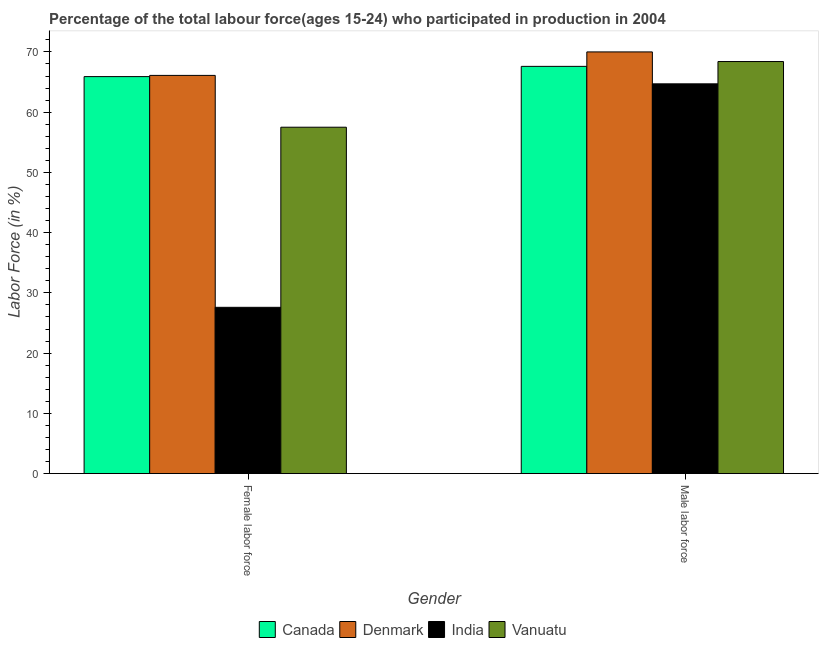How many different coloured bars are there?
Offer a very short reply. 4. How many groups of bars are there?
Provide a succinct answer. 2. Are the number of bars per tick equal to the number of legend labels?
Make the answer very short. Yes. How many bars are there on the 2nd tick from the right?
Your answer should be compact. 4. What is the label of the 1st group of bars from the left?
Keep it short and to the point. Female labor force. What is the percentage of male labour force in Canada?
Your response must be concise. 67.6. Across all countries, what is the maximum percentage of female labor force?
Keep it short and to the point. 66.1. Across all countries, what is the minimum percentage of female labor force?
Keep it short and to the point. 27.6. In which country was the percentage of female labor force maximum?
Keep it short and to the point. Denmark. What is the total percentage of male labour force in the graph?
Keep it short and to the point. 270.7. What is the difference between the percentage of female labor force in India and that in Canada?
Your answer should be compact. -38.3. What is the difference between the percentage of female labor force in Denmark and the percentage of male labour force in Canada?
Ensure brevity in your answer.  -1.5. What is the average percentage of female labor force per country?
Your response must be concise. 54.28. What is the difference between the percentage of male labour force and percentage of female labor force in Canada?
Your answer should be very brief. 1.7. In how many countries, is the percentage of female labor force greater than 36 %?
Make the answer very short. 3. What is the ratio of the percentage of male labour force in Vanuatu to that in India?
Give a very brief answer. 1.06. In how many countries, is the percentage of male labour force greater than the average percentage of male labour force taken over all countries?
Your answer should be very brief. 2. What does the 4th bar from the left in Female labor force represents?
Ensure brevity in your answer.  Vanuatu. What does the 3rd bar from the right in Male labor force represents?
Your answer should be very brief. Denmark. Does the graph contain any zero values?
Ensure brevity in your answer.  No. How many legend labels are there?
Offer a terse response. 4. What is the title of the graph?
Make the answer very short. Percentage of the total labour force(ages 15-24) who participated in production in 2004. What is the label or title of the Y-axis?
Your answer should be very brief. Labor Force (in %). What is the Labor Force (in %) of Canada in Female labor force?
Give a very brief answer. 65.9. What is the Labor Force (in %) in Denmark in Female labor force?
Your response must be concise. 66.1. What is the Labor Force (in %) in India in Female labor force?
Ensure brevity in your answer.  27.6. What is the Labor Force (in %) of Vanuatu in Female labor force?
Your answer should be very brief. 57.5. What is the Labor Force (in %) in Canada in Male labor force?
Provide a succinct answer. 67.6. What is the Labor Force (in %) in India in Male labor force?
Offer a very short reply. 64.7. What is the Labor Force (in %) of Vanuatu in Male labor force?
Make the answer very short. 68.4. Across all Gender, what is the maximum Labor Force (in %) of Canada?
Make the answer very short. 67.6. Across all Gender, what is the maximum Labor Force (in %) of Denmark?
Give a very brief answer. 70. Across all Gender, what is the maximum Labor Force (in %) in India?
Your answer should be compact. 64.7. Across all Gender, what is the maximum Labor Force (in %) of Vanuatu?
Your answer should be compact. 68.4. Across all Gender, what is the minimum Labor Force (in %) in Canada?
Keep it short and to the point. 65.9. Across all Gender, what is the minimum Labor Force (in %) of Denmark?
Your answer should be compact. 66.1. Across all Gender, what is the minimum Labor Force (in %) in India?
Your answer should be very brief. 27.6. Across all Gender, what is the minimum Labor Force (in %) of Vanuatu?
Make the answer very short. 57.5. What is the total Labor Force (in %) of Canada in the graph?
Give a very brief answer. 133.5. What is the total Labor Force (in %) in Denmark in the graph?
Give a very brief answer. 136.1. What is the total Labor Force (in %) in India in the graph?
Provide a short and direct response. 92.3. What is the total Labor Force (in %) of Vanuatu in the graph?
Offer a terse response. 125.9. What is the difference between the Labor Force (in %) in Canada in Female labor force and that in Male labor force?
Give a very brief answer. -1.7. What is the difference between the Labor Force (in %) in India in Female labor force and that in Male labor force?
Your answer should be compact. -37.1. What is the difference between the Labor Force (in %) in Canada in Female labor force and the Labor Force (in %) in Denmark in Male labor force?
Keep it short and to the point. -4.1. What is the difference between the Labor Force (in %) of Canada in Female labor force and the Labor Force (in %) of India in Male labor force?
Keep it short and to the point. 1.2. What is the difference between the Labor Force (in %) in Denmark in Female labor force and the Labor Force (in %) in Vanuatu in Male labor force?
Ensure brevity in your answer.  -2.3. What is the difference between the Labor Force (in %) in India in Female labor force and the Labor Force (in %) in Vanuatu in Male labor force?
Provide a short and direct response. -40.8. What is the average Labor Force (in %) of Canada per Gender?
Your response must be concise. 66.75. What is the average Labor Force (in %) in Denmark per Gender?
Ensure brevity in your answer.  68.05. What is the average Labor Force (in %) of India per Gender?
Offer a very short reply. 46.15. What is the average Labor Force (in %) of Vanuatu per Gender?
Provide a short and direct response. 62.95. What is the difference between the Labor Force (in %) of Canada and Labor Force (in %) of India in Female labor force?
Provide a short and direct response. 38.3. What is the difference between the Labor Force (in %) of Denmark and Labor Force (in %) of India in Female labor force?
Your response must be concise. 38.5. What is the difference between the Labor Force (in %) of India and Labor Force (in %) of Vanuatu in Female labor force?
Ensure brevity in your answer.  -29.9. What is the difference between the Labor Force (in %) of Canada and Labor Force (in %) of Denmark in Male labor force?
Offer a very short reply. -2.4. What is the difference between the Labor Force (in %) of Canada and Labor Force (in %) of India in Male labor force?
Provide a succinct answer. 2.9. What is the difference between the Labor Force (in %) of Canada and Labor Force (in %) of Vanuatu in Male labor force?
Offer a very short reply. -0.8. What is the difference between the Labor Force (in %) of Denmark and Labor Force (in %) of Vanuatu in Male labor force?
Give a very brief answer. 1.6. What is the ratio of the Labor Force (in %) of Canada in Female labor force to that in Male labor force?
Make the answer very short. 0.97. What is the ratio of the Labor Force (in %) of Denmark in Female labor force to that in Male labor force?
Give a very brief answer. 0.94. What is the ratio of the Labor Force (in %) of India in Female labor force to that in Male labor force?
Keep it short and to the point. 0.43. What is the ratio of the Labor Force (in %) in Vanuatu in Female labor force to that in Male labor force?
Provide a short and direct response. 0.84. What is the difference between the highest and the second highest Labor Force (in %) of India?
Provide a short and direct response. 37.1. What is the difference between the highest and the lowest Labor Force (in %) of India?
Offer a very short reply. 37.1. 